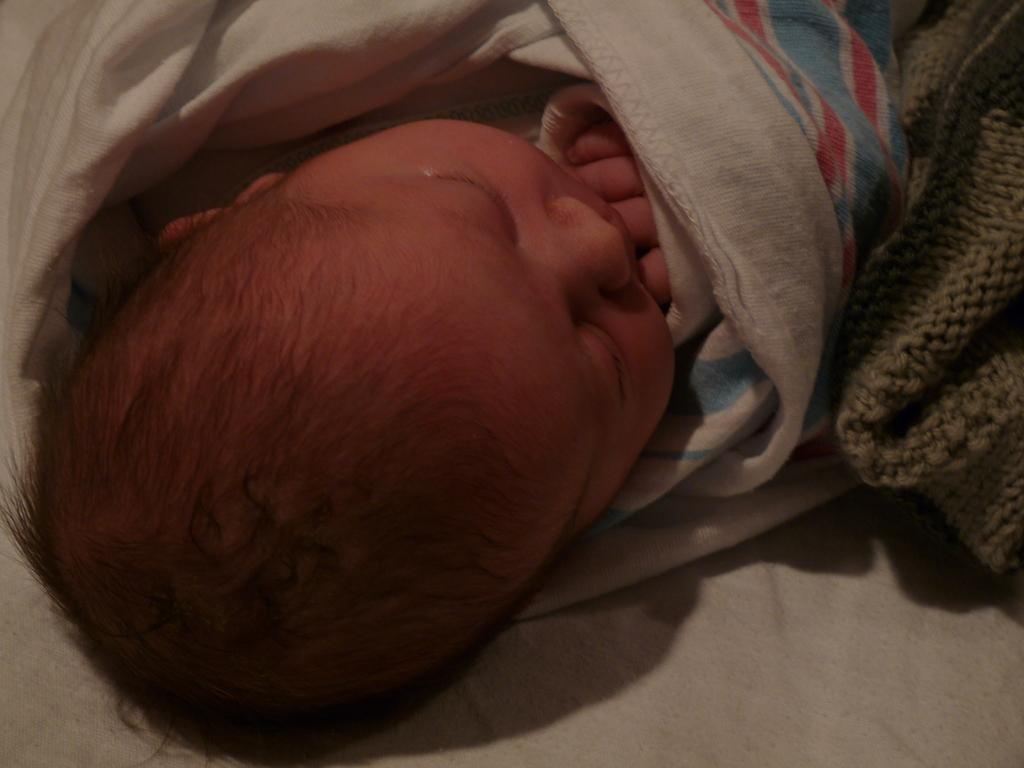What is the main subject of the image? The main subject of the image is a kid. How is the kid positioned in the image? The kid is rolled in a cloth and lying on a cloth. Are there any other cloths visible in the image? Yes, there is another cloth on the right side of the image. What type of rule is being enforced by the kid in the image? There is no indication of any rule or enforcement in the image; it simply shows a kid rolled in a cloth. 